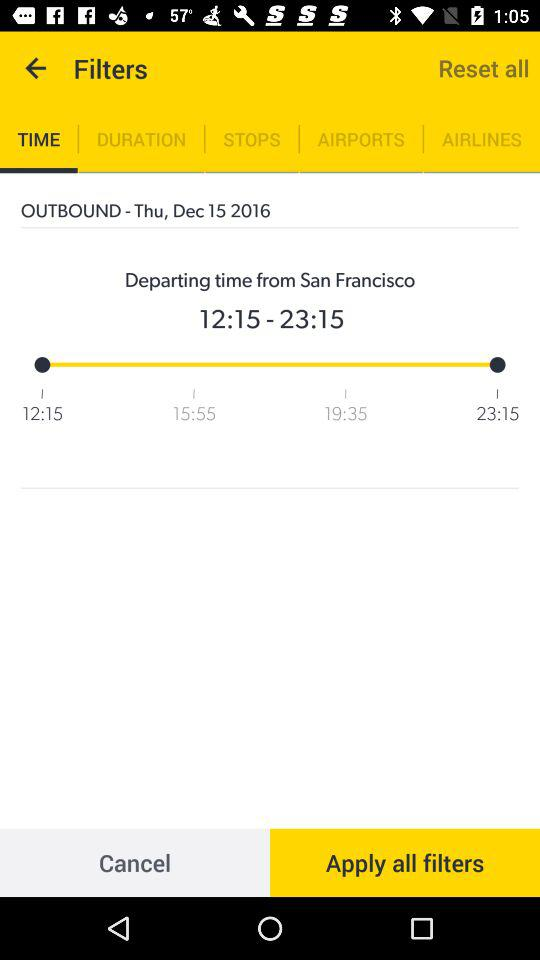What is the day on the outbound date? The day is Thursday. 